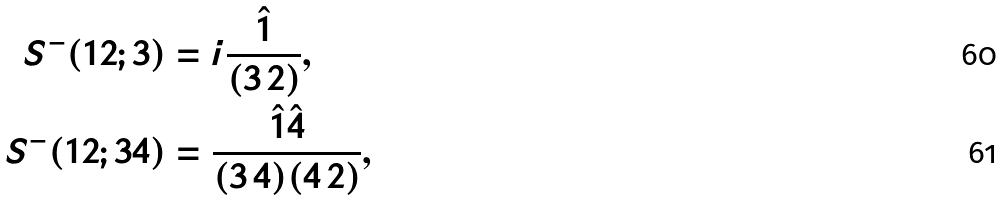Convert formula to latex. <formula><loc_0><loc_0><loc_500><loc_500>S ^ { - } ( 1 2 ; 3 ) & = i \frac { \hat { 1 } } { ( 3 \, 2 ) } , \\ S ^ { - } ( 1 2 ; 3 4 ) & = \frac { \hat { 1 } \hat { 4 } } { ( 3 \, 4 ) ( 4 \, 2 ) } ,</formula> 